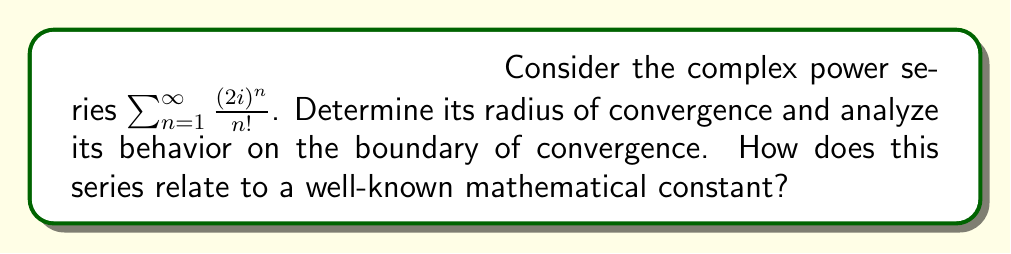Can you answer this question? Let's approach this step-by-step:

1) First, we need to determine the radius of convergence. We can use the ratio test:

   $$\lim_{n \to \infty} \left|\frac{a_{n+1}}{a_n}\right| = \lim_{n \to \infty} \left|\frac{(2i)^{n+1}/(n+1)!}{(2i)^n/n!}\right|$$

2) Simplify:
   
   $$= \lim_{n \to \infty} \left|\frac{2i}{n+1}\right| = \lim_{n \to \infty} \frac{2}{n+1} = 0$$

3) Since this limit is 0, which is less than 1, the series converges for all complex numbers. Thus, the radius of convergence is infinite.

4) Now, let's analyze the series:

   $$\sum_{n=1}^{\infty} \frac{(2i)^n}{n!} = 2i + \frac{(2i)^2}{2!} + \frac{(2i)^3}{3!} + \cdots$$

5) This is similar to the Taylor series for $e^x$, which is:

   $$e^x = 1 + x + \frac{x^2}{2!} + \frac{x^3}{3!} + \cdots$$

6) Our series is exactly this, with $x = 2i$, minus the constant term:

   $$e^{2i} - 1 = (2i) + \frac{(2i)^2}{2!} + \frac{(2i)^3}{3!} + \cdots$$

7) Therefore, our series converges to $e^{2i} - 1$.

8) This relates to Euler's formula: $e^{ix} = \cos x + i \sin x$

   For our case: $e^{2i} = \cos 2 + i \sin 2$

9) So, the sum of our series is:

   $$e^{2i} - 1 = (\cos 2 + i \sin 2) - 1 = (\cos 2 - 1) + i \sin 2$$

This series, while seeming abstract, relates to the fundamental mathematical constant $e$ and demonstrates the deep connection between complex exponentials and trigonometric functions.
Answer: $(\cos 2 - 1) + i \sin 2$ 